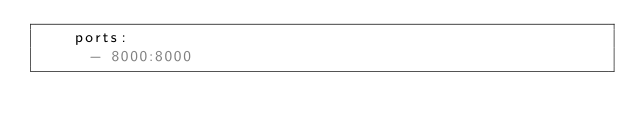<code> <loc_0><loc_0><loc_500><loc_500><_YAML_>    ports:
      - 8000:8000</code> 